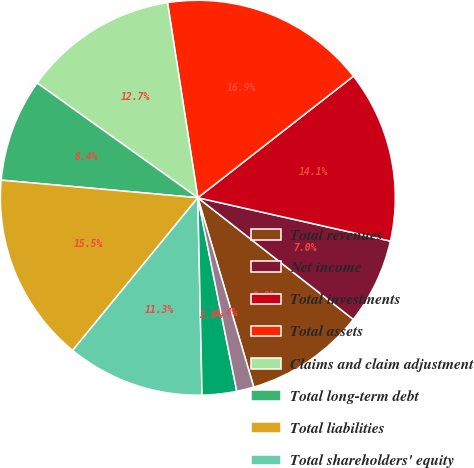Convert chart. <chart><loc_0><loc_0><loc_500><loc_500><pie_chart><fcel>Total revenues<fcel>Net income<fcel>Total investments<fcel>Total assets<fcel>Claims and claim adjustment<fcel>Total long-term debt<fcel>Total liabilities<fcel>Total shareholders' equity<fcel>Basic<fcel>Diluted<nl><fcel>9.86%<fcel>7.04%<fcel>14.08%<fcel>16.9%<fcel>12.68%<fcel>8.45%<fcel>15.49%<fcel>11.27%<fcel>2.82%<fcel>1.41%<nl></chart> 